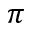<formula> <loc_0><loc_0><loc_500><loc_500>\pi</formula> 